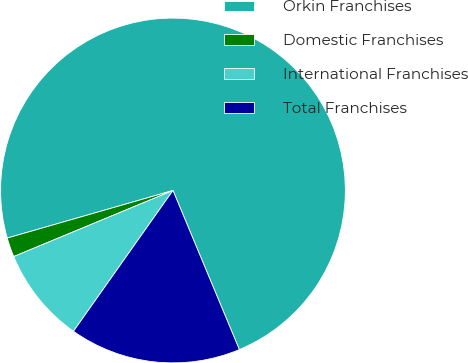Convert chart. <chart><loc_0><loc_0><loc_500><loc_500><pie_chart><fcel>Orkin Franchises<fcel>Domestic Franchises<fcel>International Franchises<fcel>Total Franchises<nl><fcel>73.15%<fcel>1.81%<fcel>8.95%<fcel>16.08%<nl></chart> 